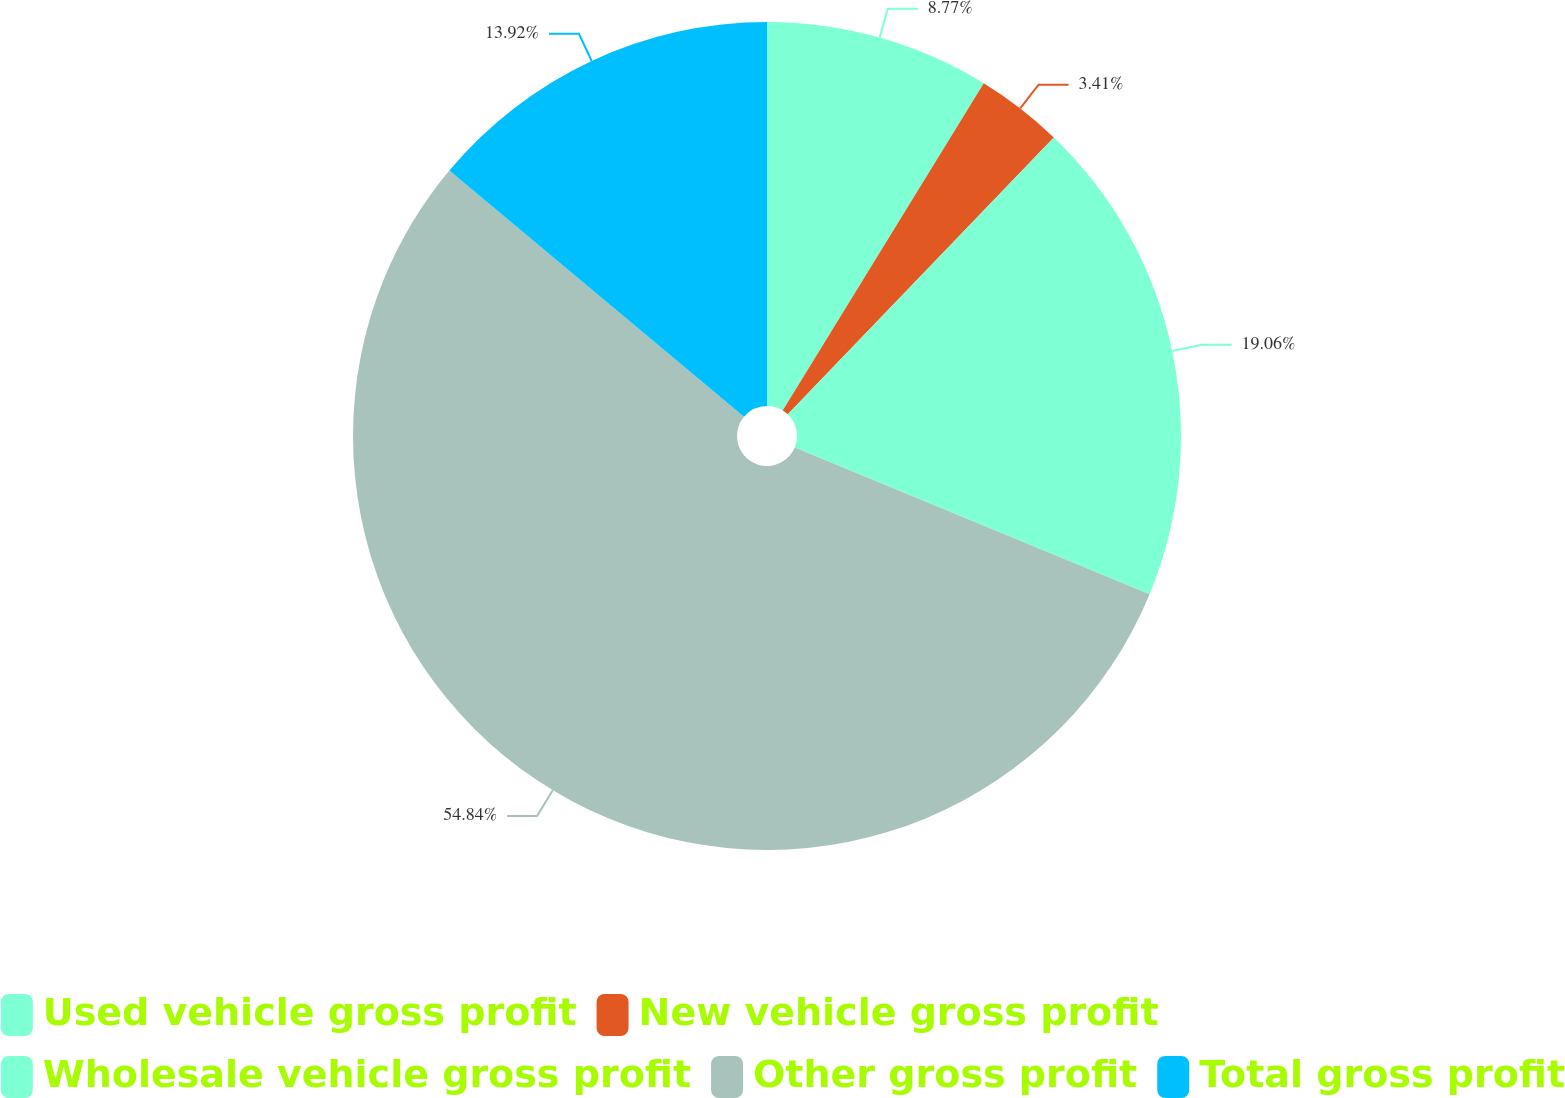<chart> <loc_0><loc_0><loc_500><loc_500><pie_chart><fcel>Used vehicle gross profit<fcel>New vehicle gross profit<fcel>Wholesale vehicle gross profit<fcel>Other gross profit<fcel>Total gross profit<nl><fcel>8.77%<fcel>3.41%<fcel>19.06%<fcel>54.84%<fcel>13.92%<nl></chart> 